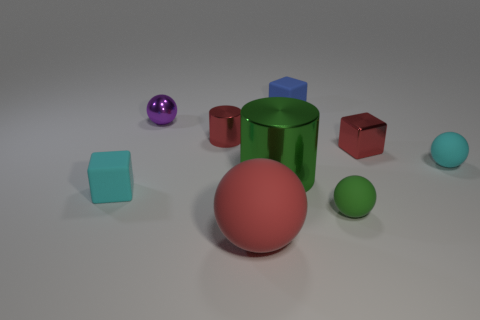Are there any small purple objects?
Offer a very short reply. Yes. There is a cyan thing on the right side of the small cube to the left of the green shiny cylinder; how many large metal things are on the left side of it?
Your response must be concise. 1. There is a large matte object; is it the same shape as the red thing that is to the left of the big rubber thing?
Keep it short and to the point. No. Is the number of green matte balls greater than the number of small brown metallic blocks?
Offer a terse response. Yes. There is a small matte thing that is on the left side of the metal sphere; is its shape the same as the purple metal thing?
Keep it short and to the point. No. Is the number of metal cylinders behind the blue matte thing greater than the number of large shiny cylinders?
Give a very brief answer. No. There is a matte block that is in front of the green thing that is left of the blue thing; what is its color?
Your answer should be compact. Cyan. How many blue blocks are there?
Keep it short and to the point. 1. What number of tiny blocks are both on the left side of the big rubber object and to the right of the small red metal cylinder?
Provide a succinct answer. 0. Is there anything else that is the same shape as the green matte thing?
Provide a succinct answer. Yes. 